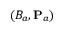<formula> <loc_0><loc_0><loc_500><loc_500>( B _ { a } , { P } _ { a } )</formula> 